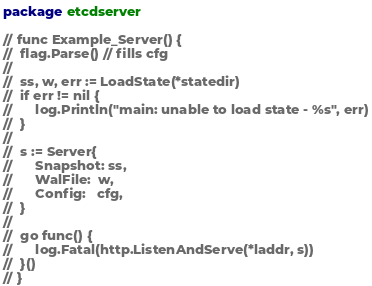<code> <loc_0><loc_0><loc_500><loc_500><_Go_>package etcdserver

// func Example_Server() {
// 	flag.Parse() // fills cfg
//
// 	ss, w, err := LoadState(*statedir)
// 	if err != nil {
// 		log.Println("main: unable to load state - %s", err)
// 	}
//
// 	s := Server{
// 		Snapshot: ss,
// 		WalFile:  w,
// 		Config:   cfg,
// 	}
//
// 	go func() {
// 		log.Fatal(http.ListenAndServe(*laddr, s))
// 	}()
// }
</code> 